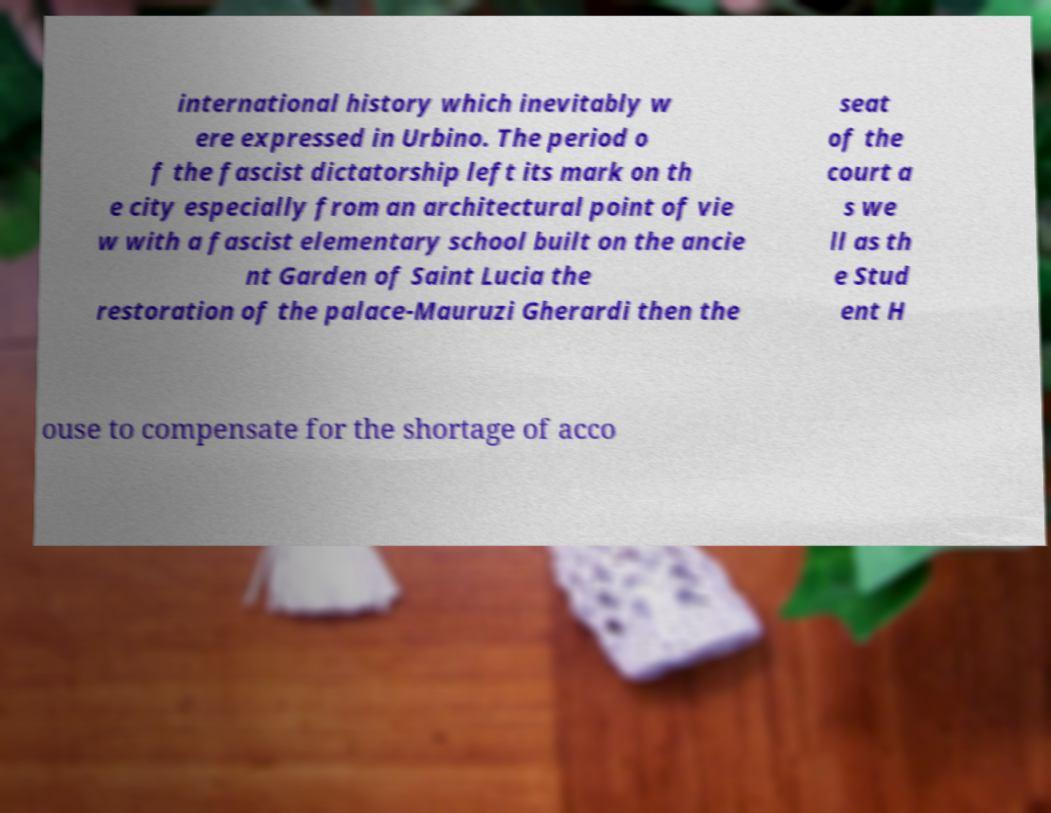Can you read and provide the text displayed in the image?This photo seems to have some interesting text. Can you extract and type it out for me? international history which inevitably w ere expressed in Urbino. The period o f the fascist dictatorship left its mark on th e city especially from an architectural point of vie w with a fascist elementary school built on the ancie nt Garden of Saint Lucia the restoration of the palace-Mauruzi Gherardi then the seat of the court a s we ll as th e Stud ent H ouse to compensate for the shortage of acco 